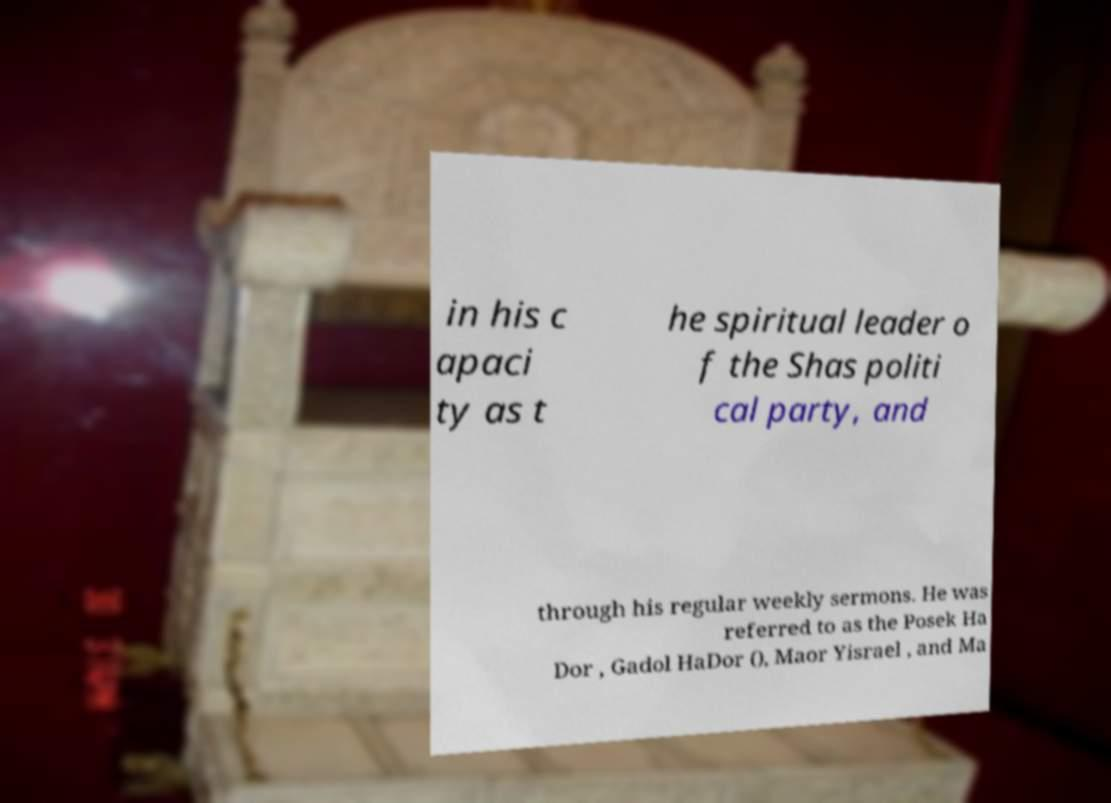What messages or text are displayed in this image? I need them in a readable, typed format. in his c apaci ty as t he spiritual leader o f the Shas politi cal party, and through his regular weekly sermons. He was referred to as the Posek Ha Dor , Gadol HaDor (), Maor Yisrael , and Ma 